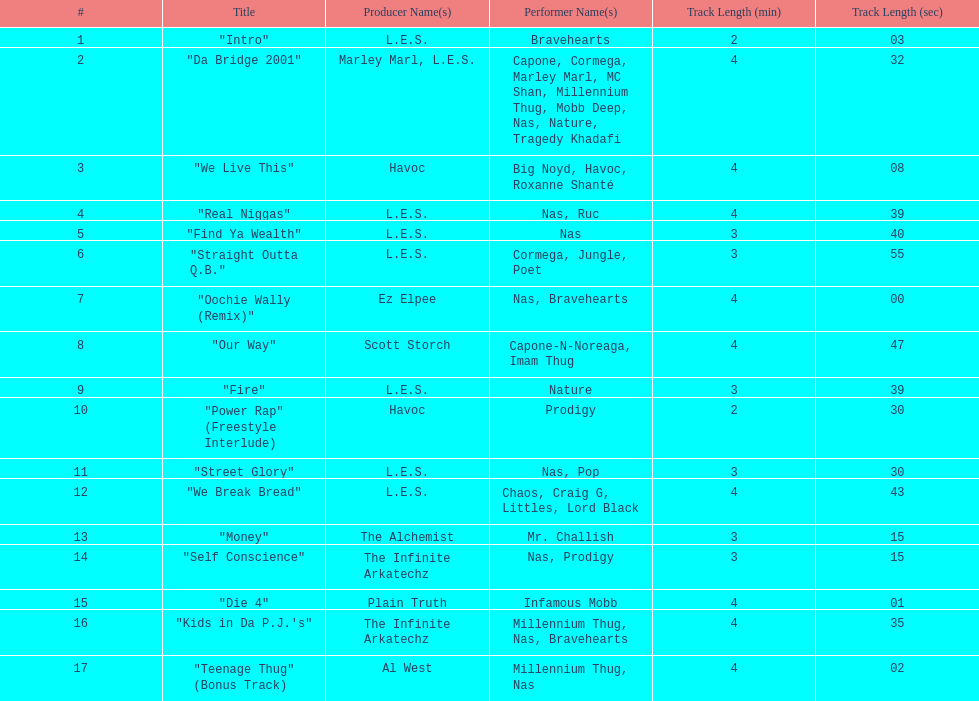Who produced the last track of the album? Al West. 